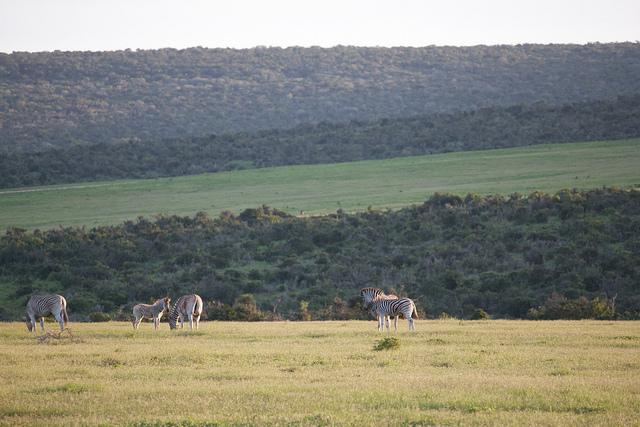How many zebras are sitting atop of the grassy field? four 